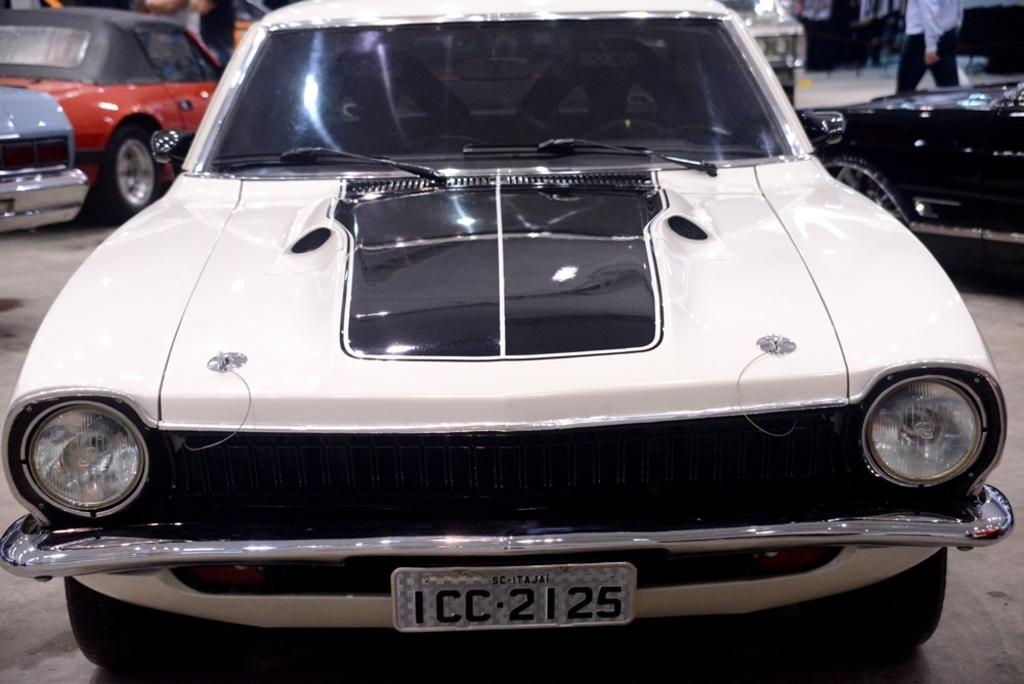What is the main subject in the center of the image? There is a car in the center of the image. What color is the car? The car is white in color. What else can be seen in the background of the image? There are other cars and people in the background of the image. Are there any flames coming out of the car in the image? No, there are no flames present in the image, and the car is not on fire. How many chickens can be seen in the image? There are no chickens present in the image. 